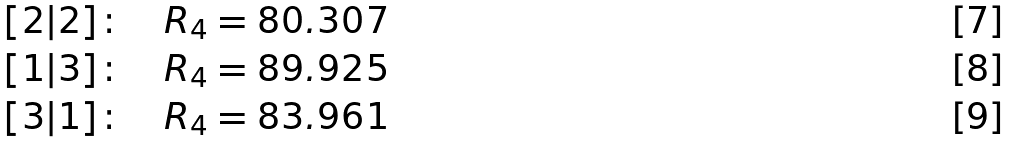<formula> <loc_0><loc_0><loc_500><loc_500>[ 2 | 2 ] \colon \quad R _ { 4 } = 8 0 . 3 0 7 \\ [ 1 | 3 ] \colon \quad R _ { 4 } = 8 9 . 9 2 5 \\ [ 3 | 1 ] \colon \quad R _ { 4 } = 8 3 . 9 6 1</formula> 